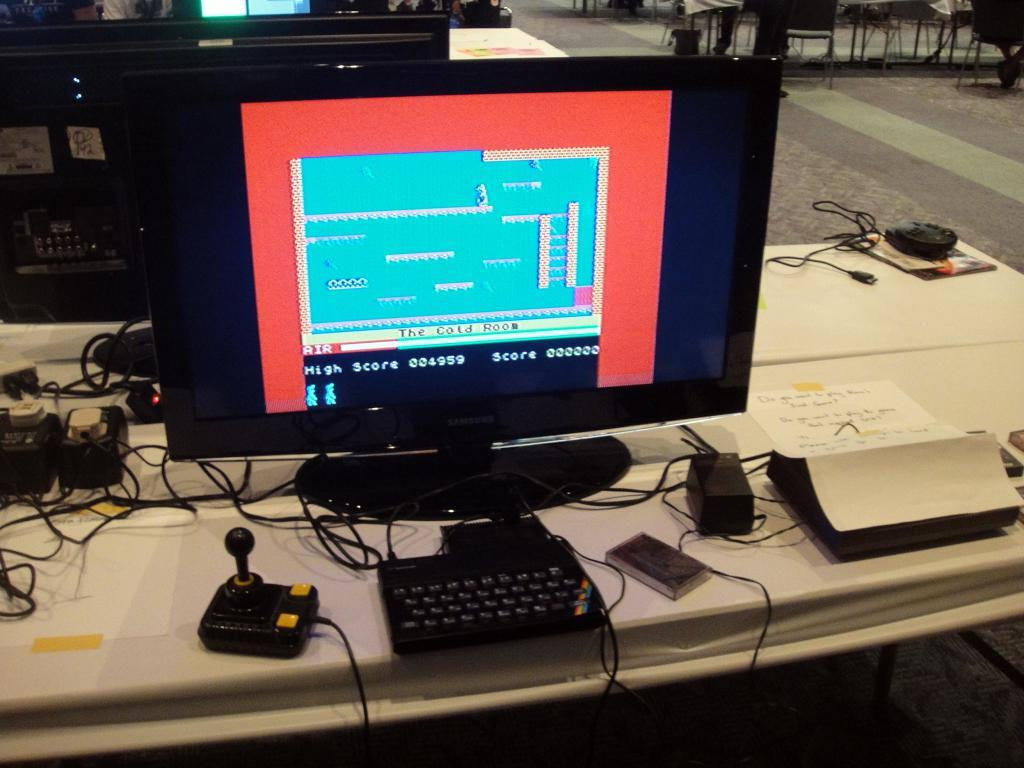<image>
Provide a brief description of the given image. The game shows that they are currently in The Cold Room. 